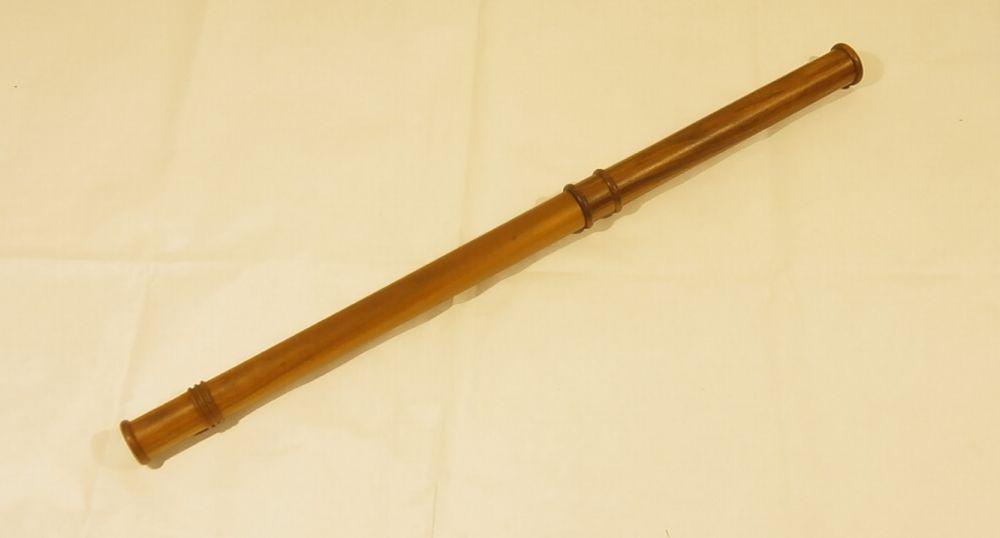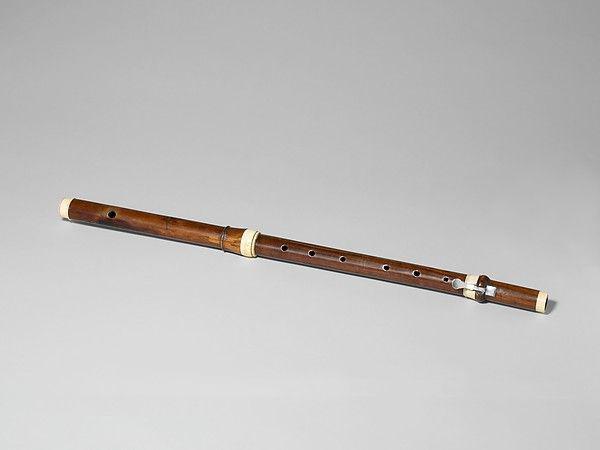The first image is the image on the left, the second image is the image on the right. For the images shown, is this caption "There are two instruments." true? Answer yes or no. Yes. The first image is the image on the left, the second image is the image on the right. Evaluate the accuracy of this statement regarding the images: "There are exactly two flutes.". Is it true? Answer yes or no. Yes. 